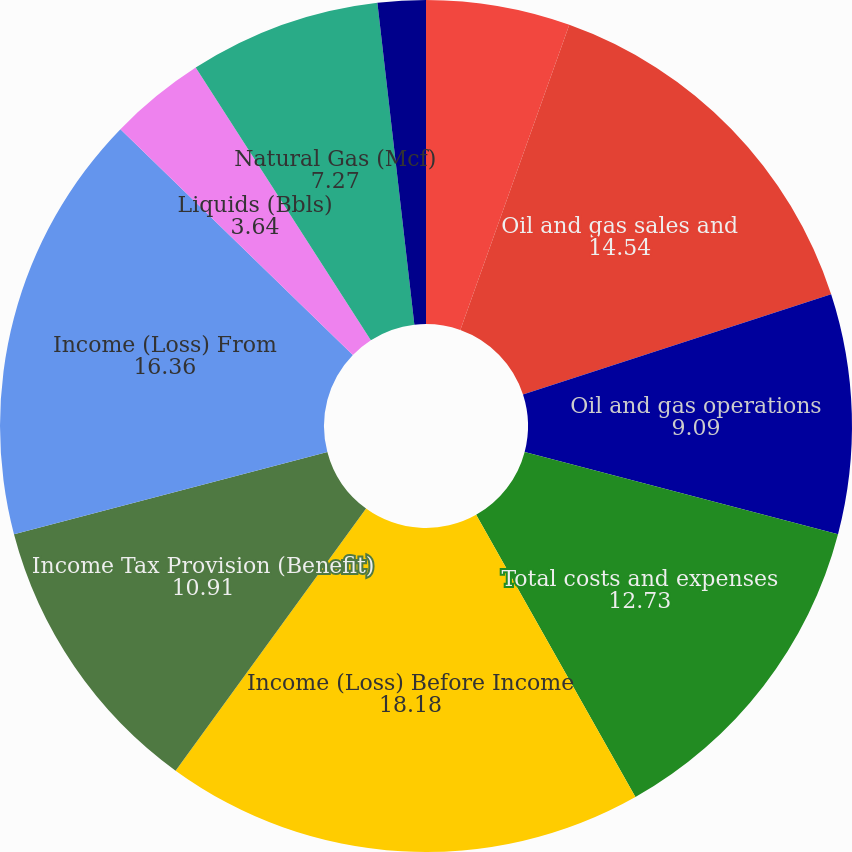Convert chart. <chart><loc_0><loc_0><loc_500><loc_500><pie_chart><fcel>(dollars in thousands)<fcel>Oil and gas sales and<fcel>Oil and gas operations<fcel>Total costs and expenses<fcel>Income (Loss) Before Income<fcel>Income Tax Provision (Benefit)<fcel>Income (Loss) From<fcel>Liquids (Bbls)<fcel>Natural Gas (Mcf)<fcel>Liquids (/Bbl)<nl><fcel>5.46%<fcel>14.54%<fcel>9.09%<fcel>12.73%<fcel>18.18%<fcel>10.91%<fcel>16.36%<fcel>3.64%<fcel>7.27%<fcel>1.82%<nl></chart> 